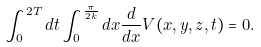Convert formula to latex. <formula><loc_0><loc_0><loc_500><loc_500>\int _ { 0 } ^ { 2 T } d t \int _ { 0 } ^ { \frac { \pi } { 2 k } } d x \frac { d } { d x } V ( x , y , z , t ) = 0 .</formula> 